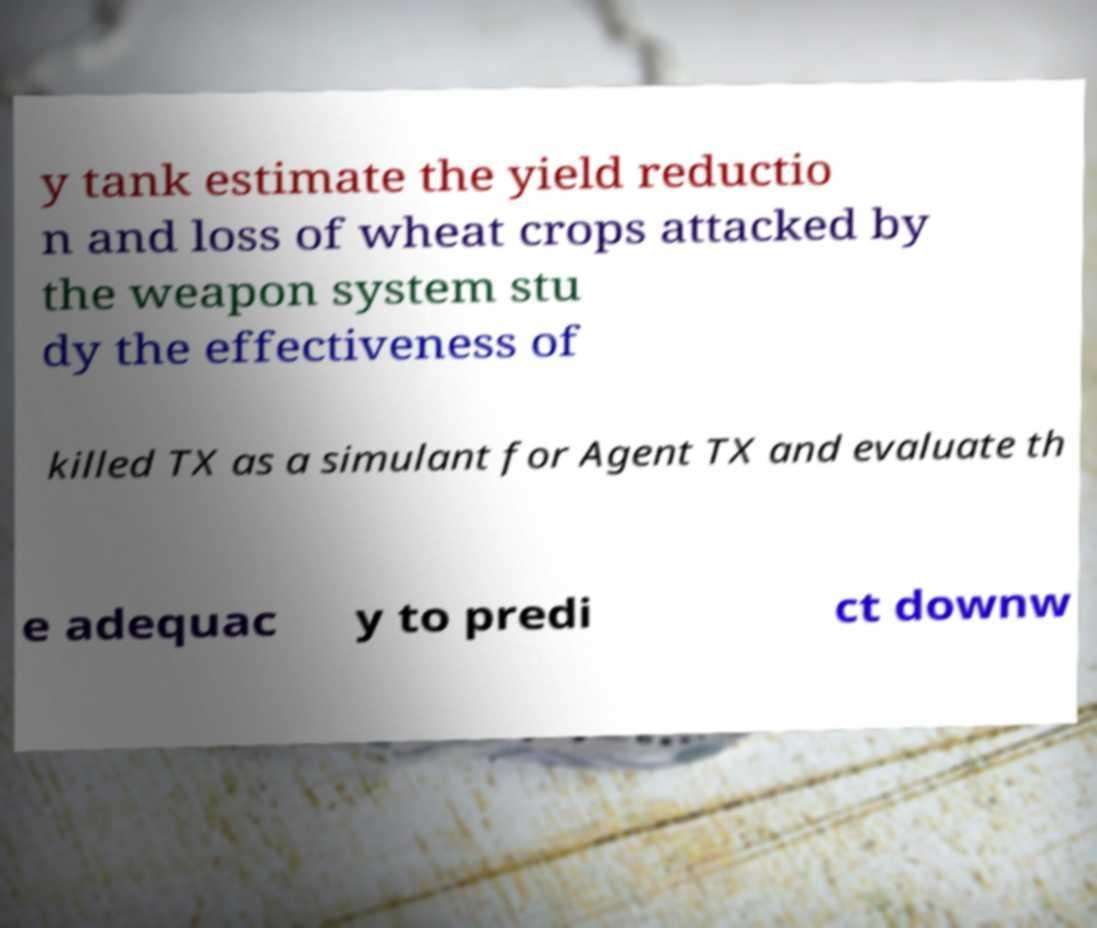What messages or text are displayed in this image? I need them in a readable, typed format. y tank estimate the yield reductio n and loss of wheat crops attacked by the weapon system stu dy the effectiveness of killed TX as a simulant for Agent TX and evaluate th e adequac y to predi ct downw 